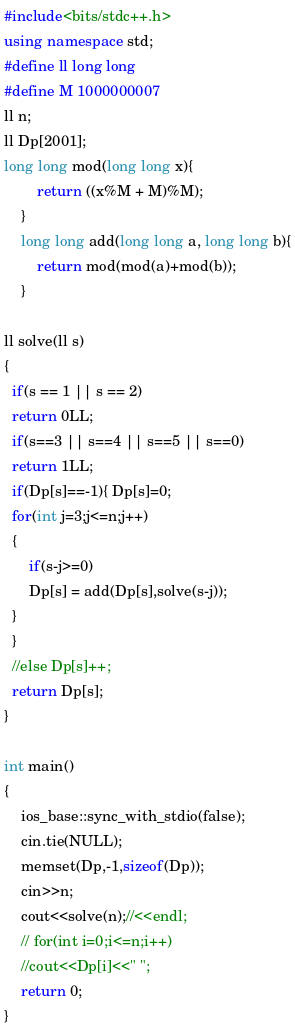<code> <loc_0><loc_0><loc_500><loc_500><_C++_>#include<bits/stdc++.h>
using namespace std;
#define ll long long
#define M 1000000007
ll n;
ll Dp[2001];
long long mod(long long x){
        return ((x%M + M)%M);
    }
    long long add(long long a, long long b){
        return mod(mod(a)+mod(b));
    }
    
ll solve(ll s)
{
  if(s == 1 || s == 2)
  return 0LL;
  if(s==3 || s==4 || s==5 || s==0)
  return 1LL;
  if(Dp[s]==-1){ Dp[s]=0;
  for(int j=3;j<=n;j++)
  {
      if(s-j>=0)
      Dp[s] = add(Dp[s],solve(s-j));
  }
  }
  //else Dp[s]++;
  return Dp[s];
}

int main()
{
    ios_base::sync_with_stdio(false);
    cin.tie(NULL);
    memset(Dp,-1,sizeof(Dp));
    cin>>n;
    cout<<solve(n);//<<endl;
    // for(int i=0;i<=n;i++)
    //cout<<Dp[i]<<" ";
    return 0;
}</code> 